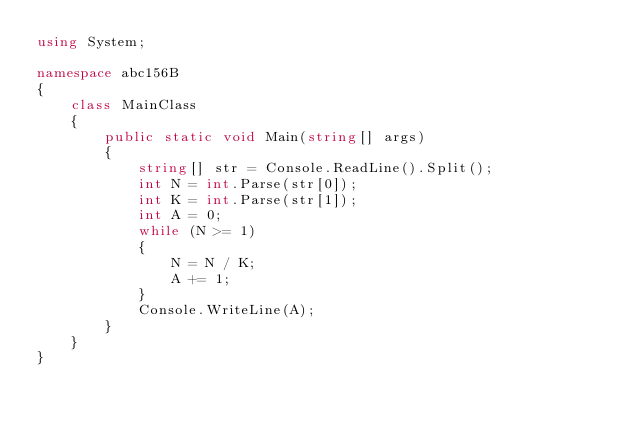<code> <loc_0><loc_0><loc_500><loc_500><_C#_>using System;

namespace abc156B
{
    class MainClass
    {
        public static void Main(string[] args)
        {
            string[] str = Console.ReadLine().Split();
            int N = int.Parse(str[0]);
            int K = int.Parse(str[1]);
            int A = 0;
            while (N >= 1)
            {
                N = N / K;
                A += 1;
            }
            Console.WriteLine(A);
        }
    }
}
</code> 